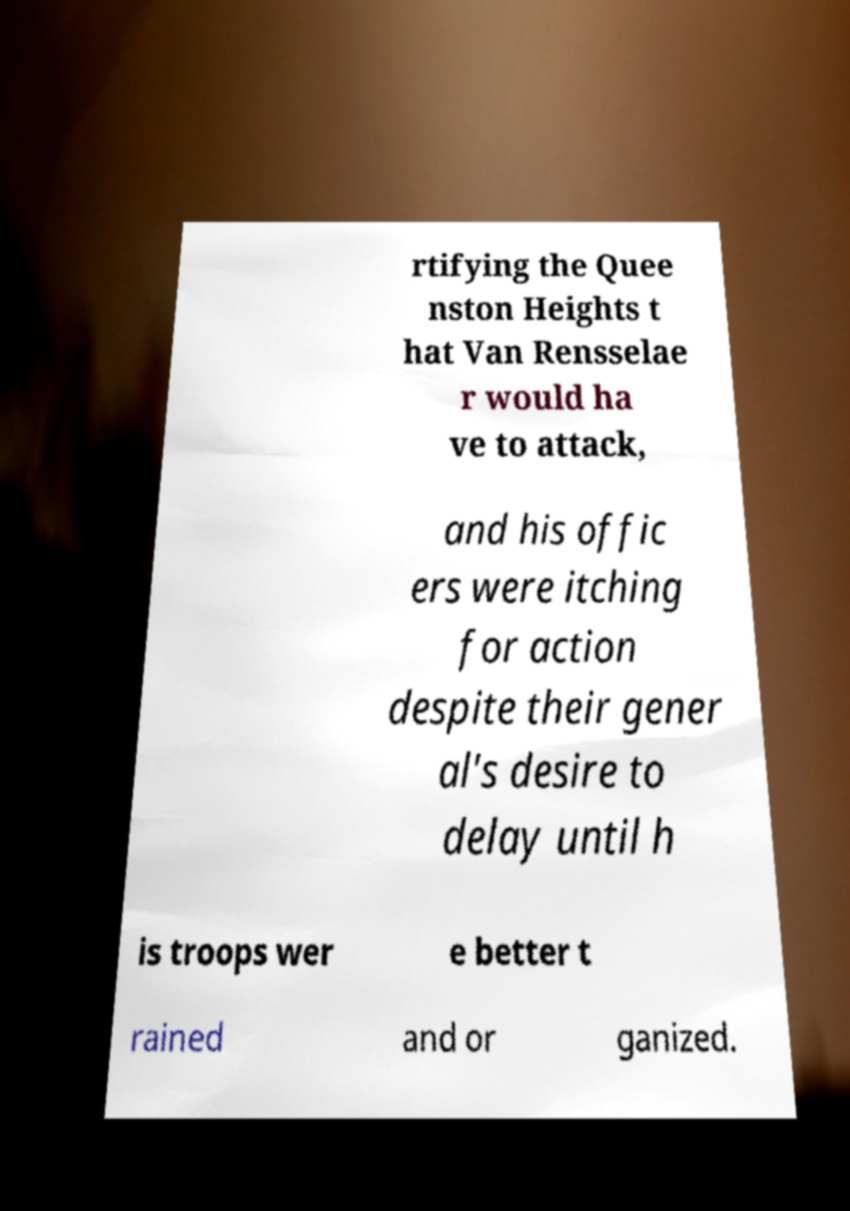For documentation purposes, I need the text within this image transcribed. Could you provide that? rtifying the Quee nston Heights t hat Van Rensselae r would ha ve to attack, and his offic ers were itching for action despite their gener al's desire to delay until h is troops wer e better t rained and or ganized. 